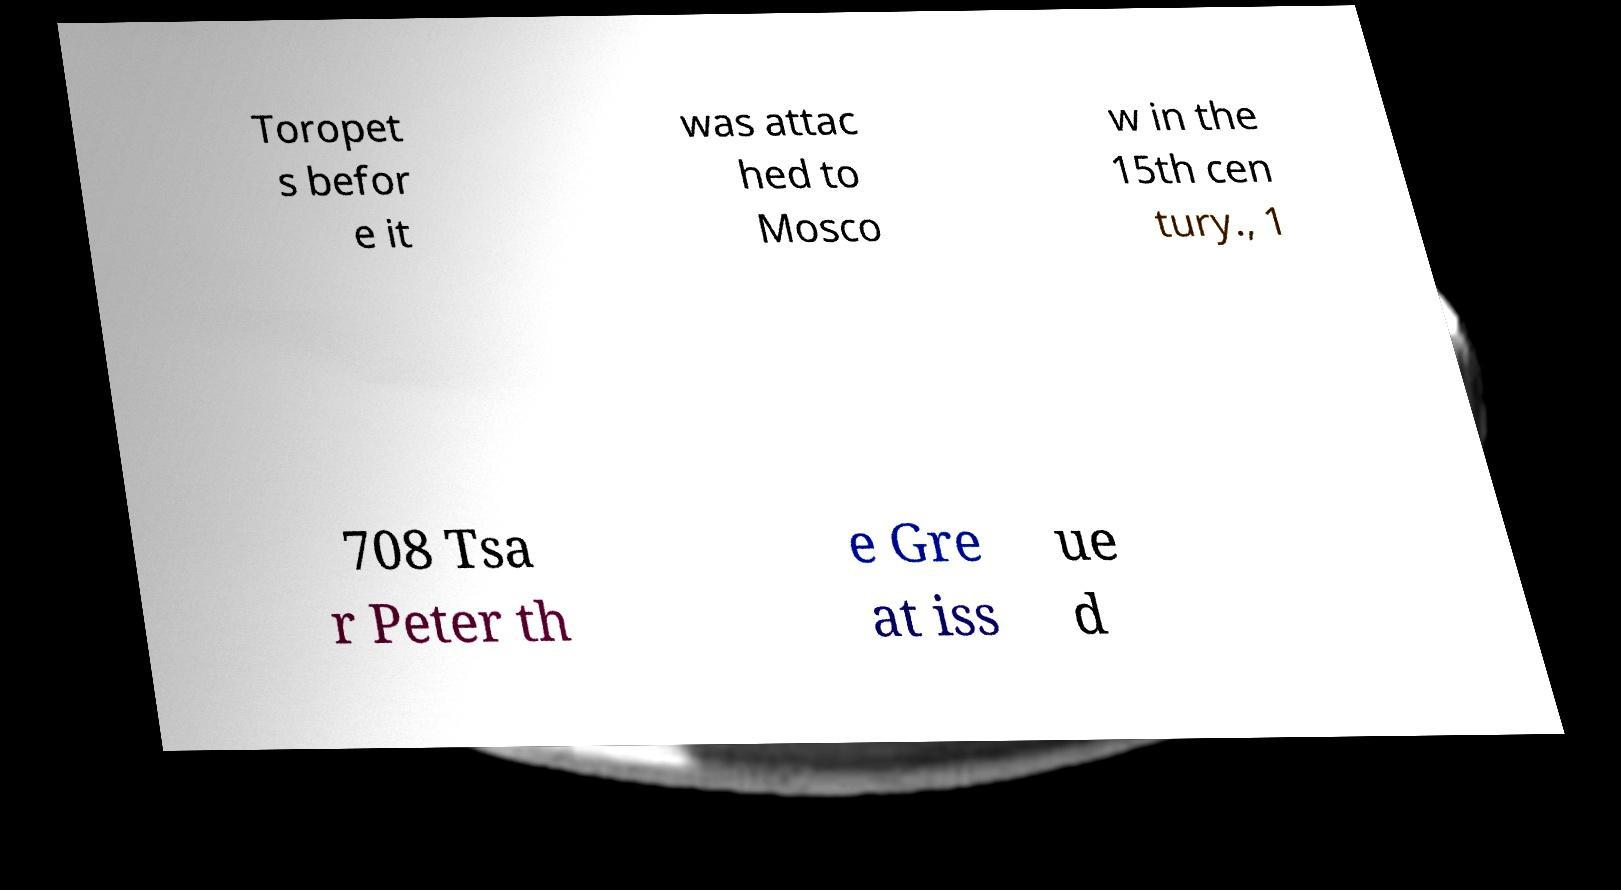Please read and relay the text visible in this image. What does it say? Toropet s befor e it was attac hed to Mosco w in the 15th cen tury., 1 708 Tsa r Peter th e Gre at iss ue d 